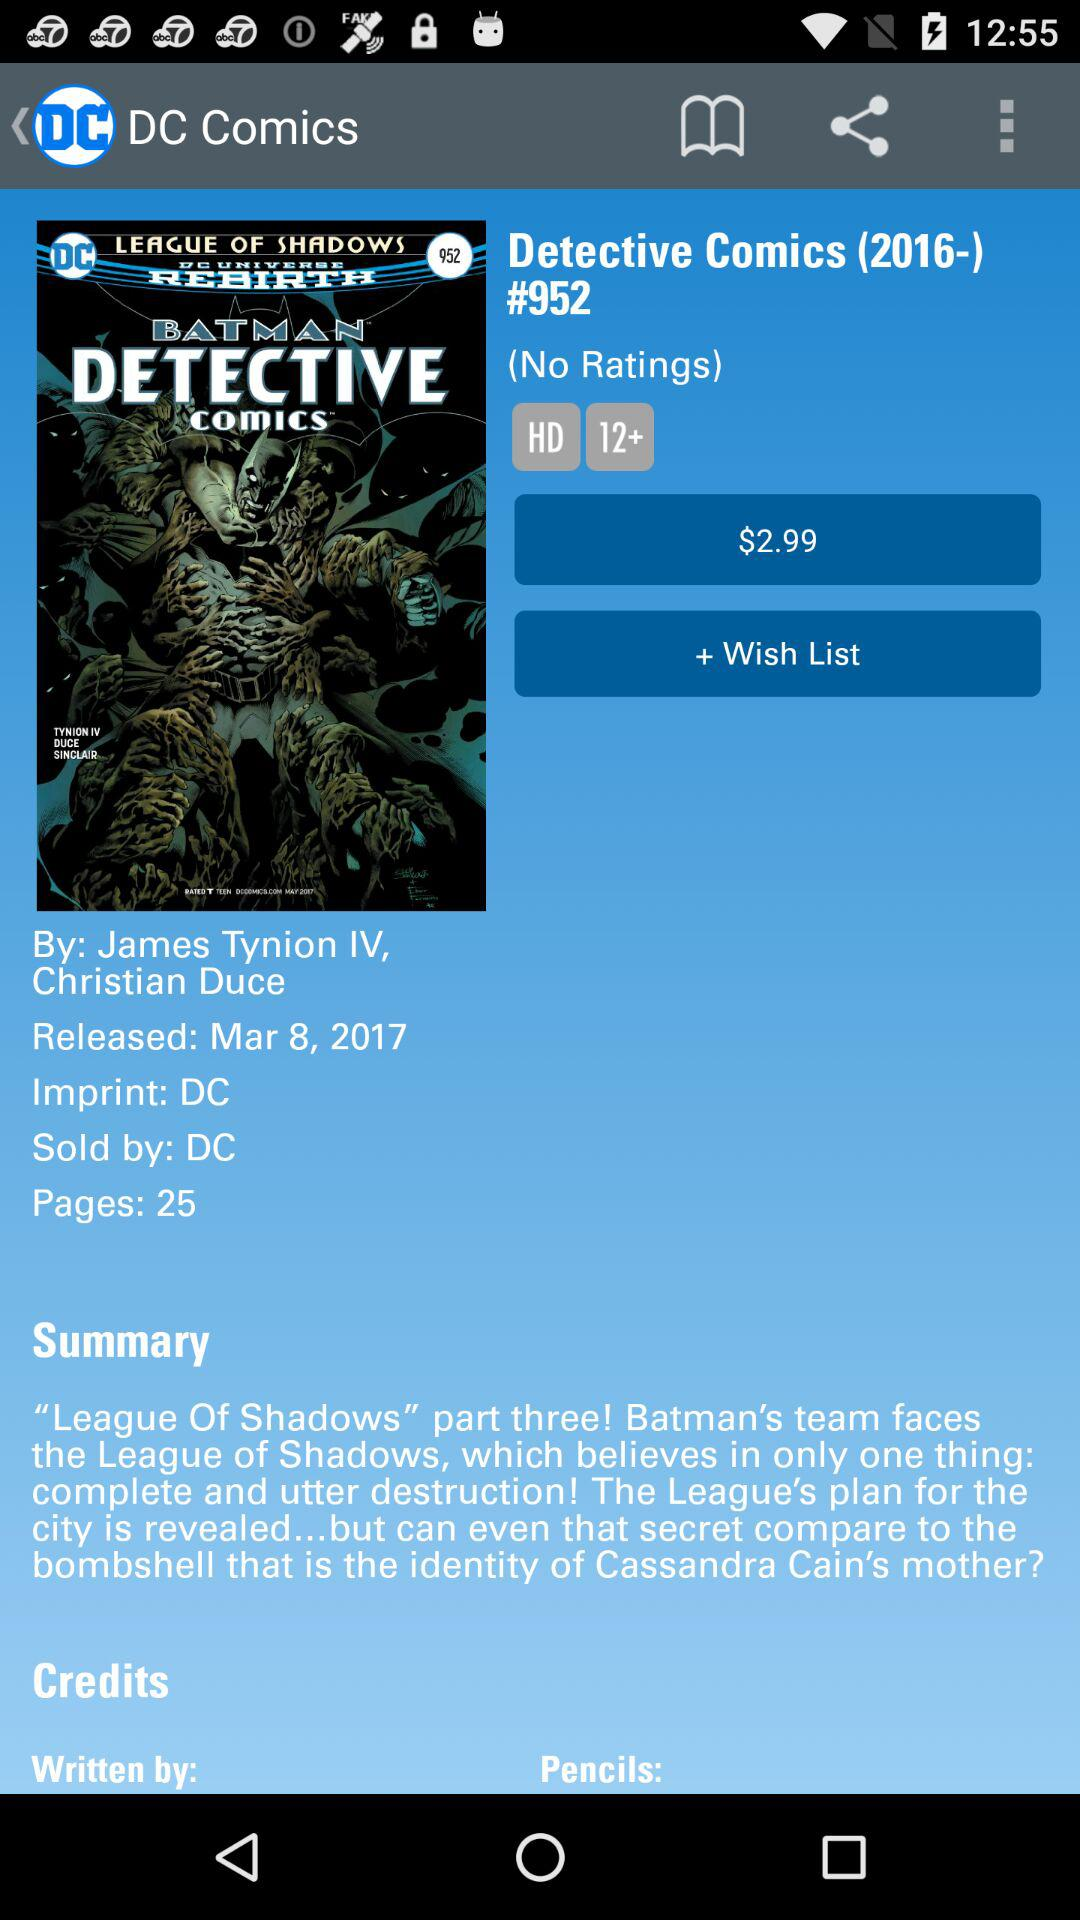What is the total number of pages? The total number of pages is 25. 